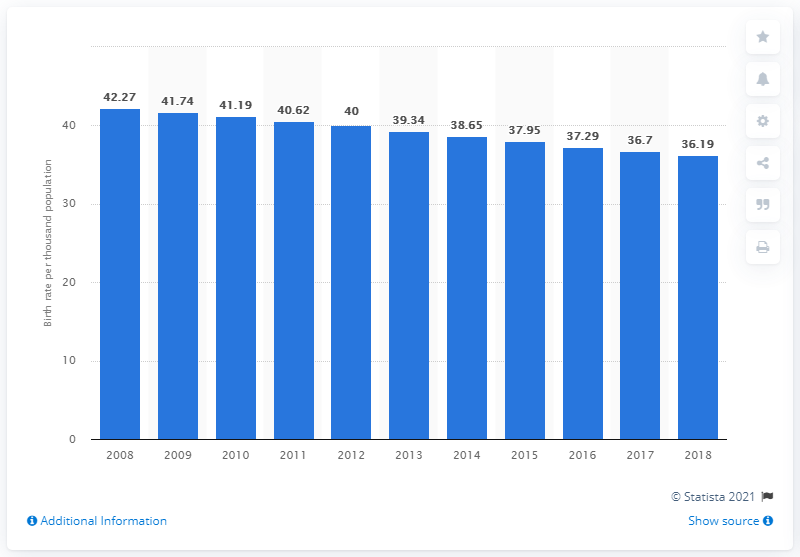Mention a couple of crucial points in this snapshot. In 2018, the crude birth rate in Zambia was 36.19. 